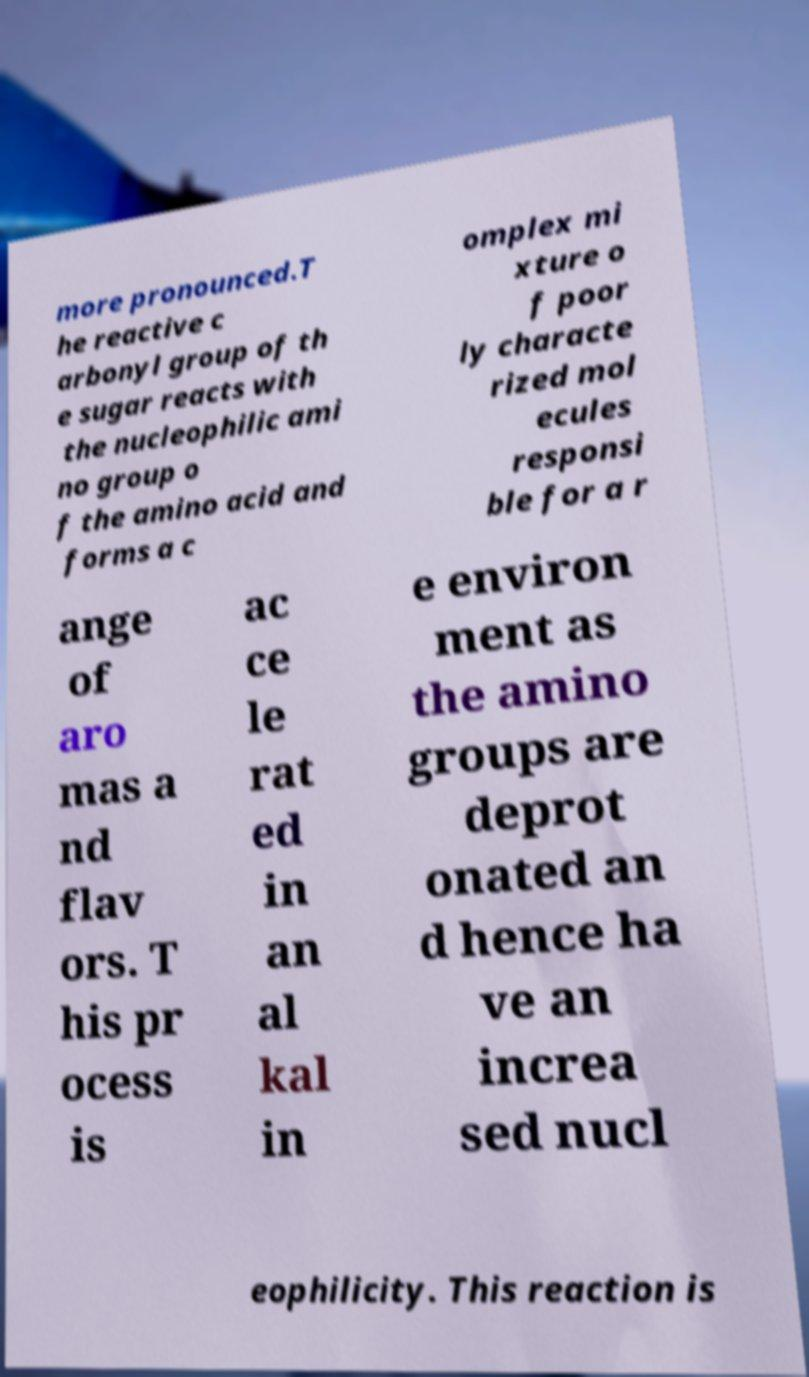Can you read and provide the text displayed in the image?This photo seems to have some interesting text. Can you extract and type it out for me? more pronounced.T he reactive c arbonyl group of th e sugar reacts with the nucleophilic ami no group o f the amino acid and forms a c omplex mi xture o f poor ly characte rized mol ecules responsi ble for a r ange of aro mas a nd flav ors. T his pr ocess is ac ce le rat ed in an al kal in e environ ment as the amino groups are deprot onated an d hence ha ve an increa sed nucl eophilicity. This reaction is 